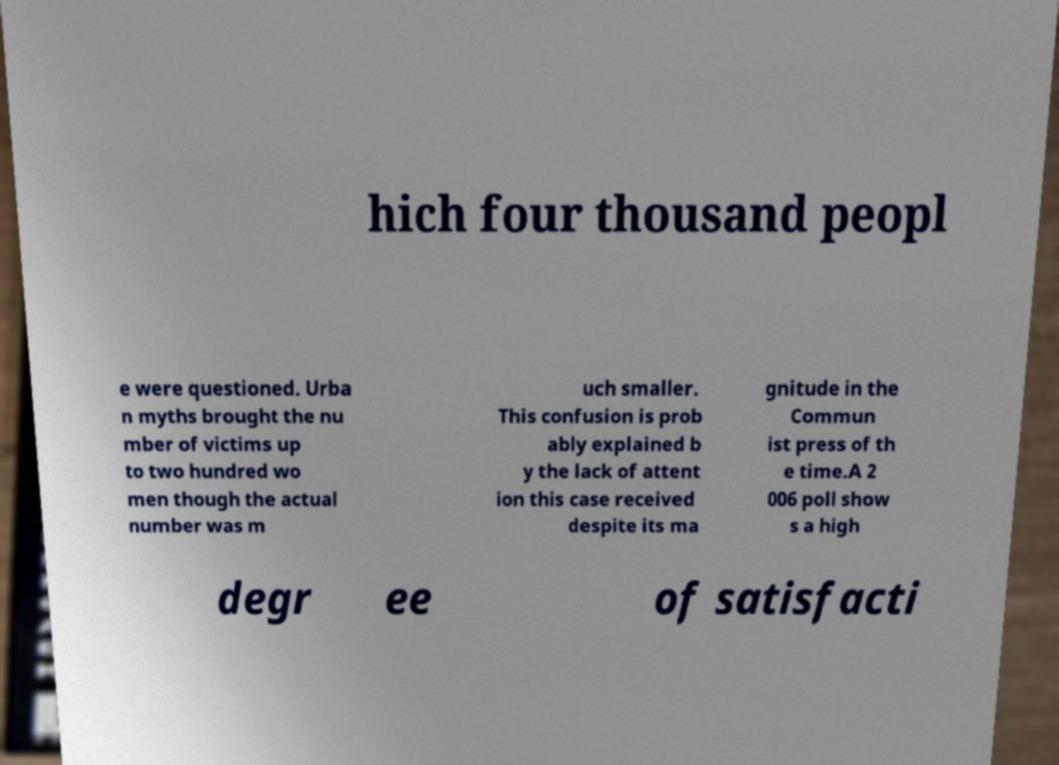Please read and relay the text visible in this image. What does it say? hich four thousand peopl e were questioned. Urba n myths brought the nu mber of victims up to two hundred wo men though the actual number was m uch smaller. This confusion is prob ably explained b y the lack of attent ion this case received despite its ma gnitude in the Commun ist press of th e time.A 2 006 poll show s a high degr ee of satisfacti 